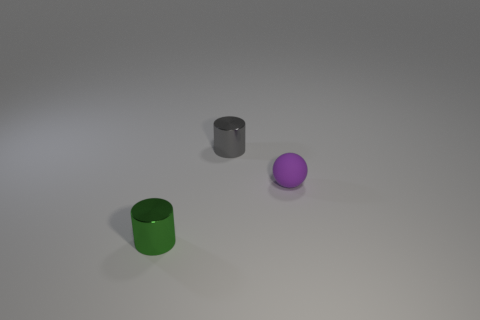Add 2 large cyan spheres. How many objects exist? 5 Subtract all cylinders. How many objects are left? 1 Subtract 0 brown spheres. How many objects are left? 3 Subtract all shiny objects. Subtract all tiny rubber spheres. How many objects are left? 0 Add 2 small green cylinders. How many small green cylinders are left? 3 Add 2 big red objects. How many big red objects exist? 2 